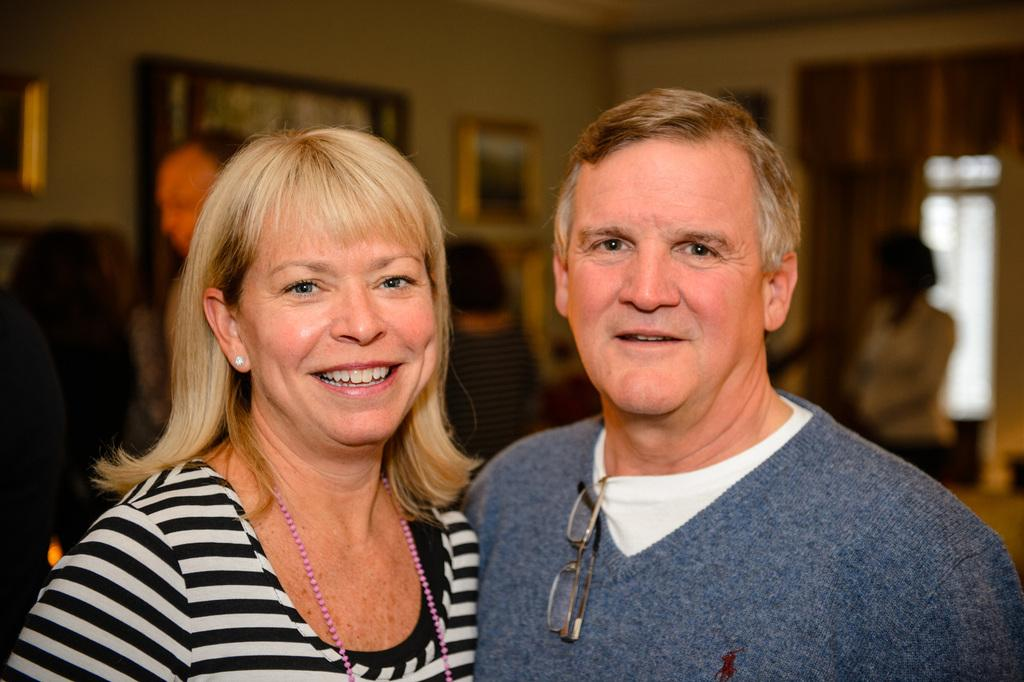Who or what can be seen in the image? There are people in the image. What is present in the background of the image? There is a wall in the image. Are there any decorative items visible in the image? Yes, there are photo frames in the image. How many people are standing in the front of the image? Two people are standing in the front of the image. Can you describe the background of the image? The background of the image is slightly blurred. What type of design can be seen on the ant in the image? There are no ants present in the image, so it is not possible to determine the design on an ant. Is there any oil visible in the image? There is no oil present in the image. 